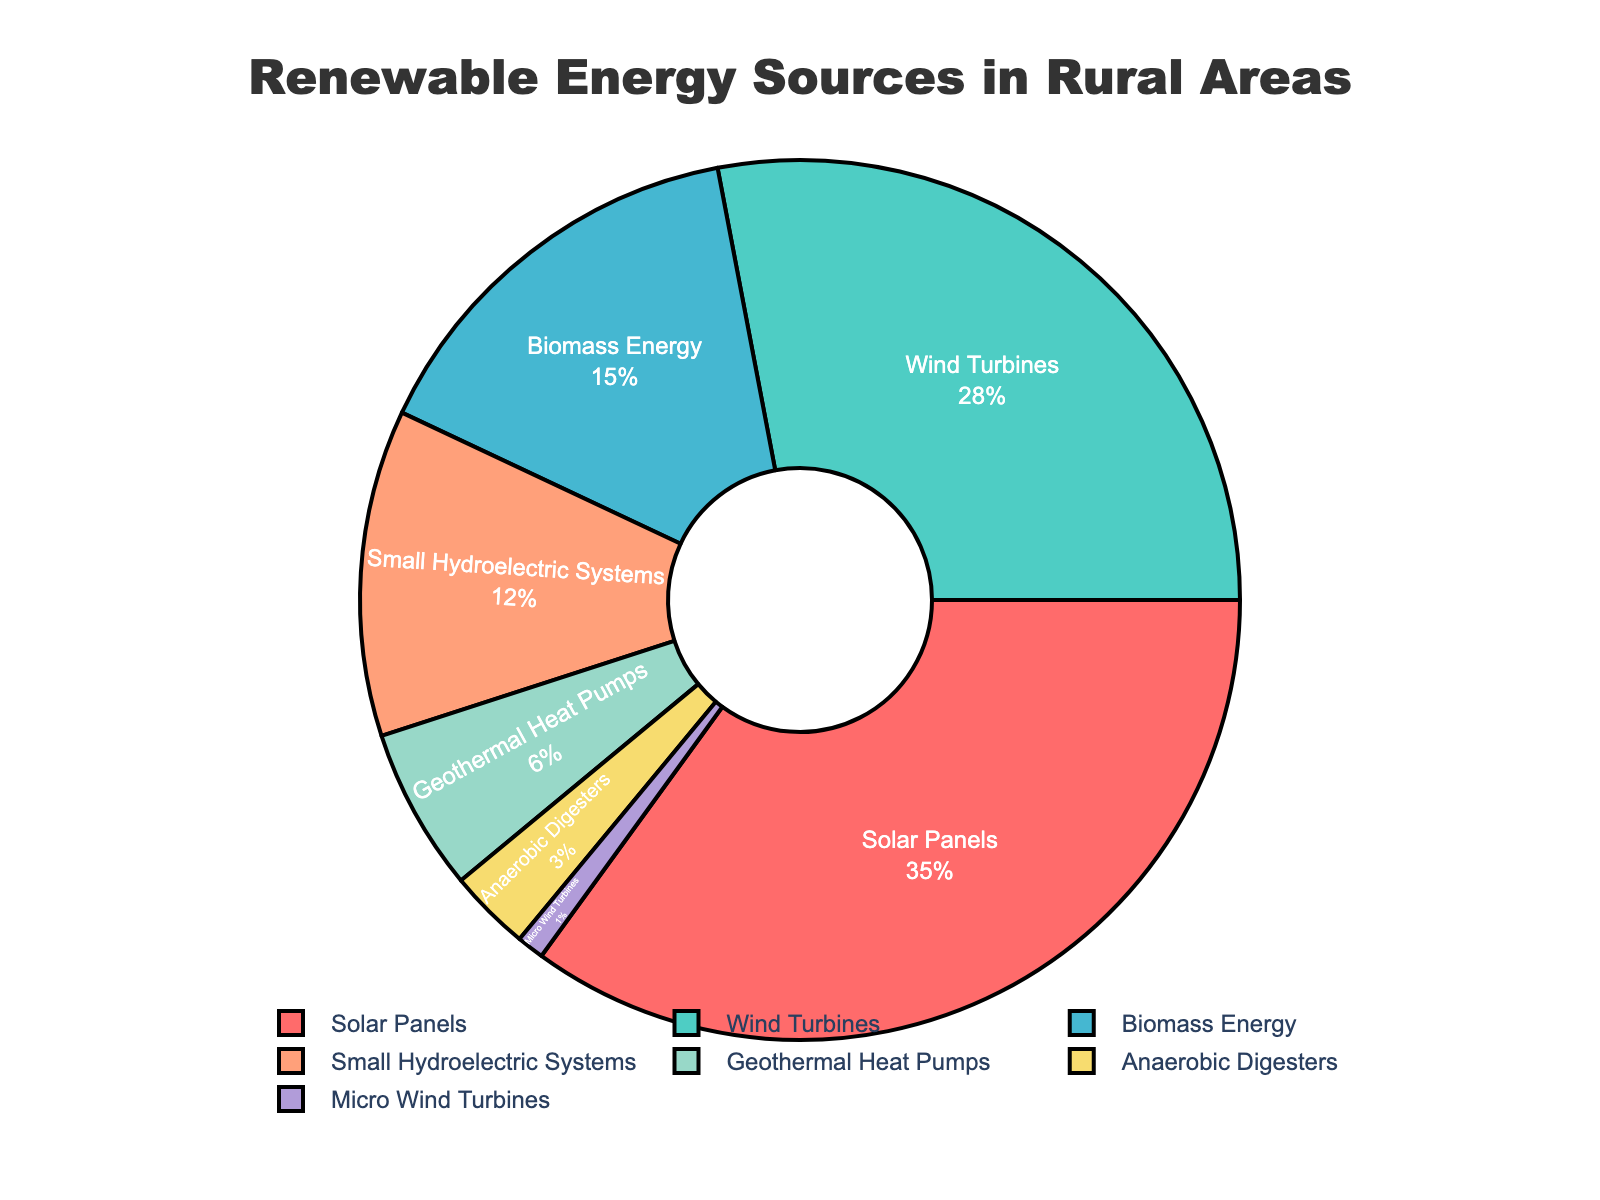What's the most adopted renewable energy source in rural areas? The figure shows the different sources of renewable energy with their corresponding percentages. The largest segment in the pie chart represents solar panels with 35%. Therefore, solar panels are the most adopted renewable energy source in rural areas.
Answer: Solar Panels Which renewable energy source is the least adopted according to the pie chart? By visually inspecting the smallest segment of the pie chart, micro wind turbines are seen to have the smallest percentage at 1%. Hence, micro wind turbines are the least adopted.
Answer: Micro Wind Turbines What are the combined percentages of biomass energy and small hydroelectric systems? The pie chart provides the individual percentages for biomass energy (15%) and small hydroelectric systems (12%). Adding these together: 15% + 12% = 27%.
Answer: 27% How does the percentage of wind turbines compare to that of anaerobic digesters? The pie chart shows that wind turbines have a percentage of 28%, while anaerobic digesters have 3%. Comparing these, wind turbines have a higher adoption rate.
Answer: Wind Turbines have a higher adoption rate What is the difference in adoption rates between solar panels and geothermal heat pumps? The chart shows the adoption rate of solar panels is 35% and geothermal heat pumps is 6%. Subtracting these two gives 35% - 6% = 29%.
Answer: 29% What color is associated with the segment representing wind turbines in the pie chart? Observing the colors used in the pie chart, the segment for wind turbines is represented by green.
Answer: Green How much more popular are solar panels compared to biomass energy? From the chart, solar panels have a 35% adoption rate and biomass energy has 15%. To find how much more popular solar panels are, subtract the biomass energy percentage from the solar panels percentage: 35% - 15% = 20%.
Answer: 20% If you combine the adoption rates of the top three renewable energy sources, what is the total? The top three renewable energy sources by percentage are solar panels (35%), wind turbines (28%), and biomass energy (15%). Adding these percentages together: 35% + 28% + 15% = 78%.
Answer: 78% Which energy source represents the middle value when the sources are ordered from highest to lowest percentage? Arranging the sources in decreasing order gives: solar panels (35%), wind turbines (28%), biomass energy (15%), small hydroelectric systems (12%), geothermal heat pumps (6%), anaerobic digesters (3%), micro wind turbines (1%). The middle value in this list is small hydroelectric systems with 12%.
Answer: Small Hydroelectric Systems Is the adoption rate of geothermal heat pumps more or less than half the adoption rate of wind turbines? Geothermal heat pumps have a 6% adoption rate and wind turbines have a 28% adoption rate. Half of the wind turbines' rate is 28% / 2 = 14%. Comparing, 6% is less than 14%.
Answer: Less 